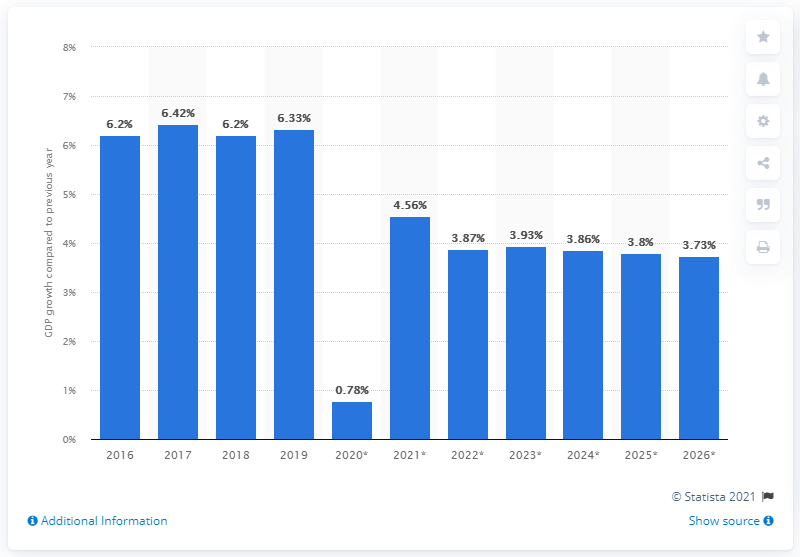Outline some significant characteristics in this image. In 2016, the real Gross Domestic Product (GDP) of Turkmenistan grew by 6.33 percent. 